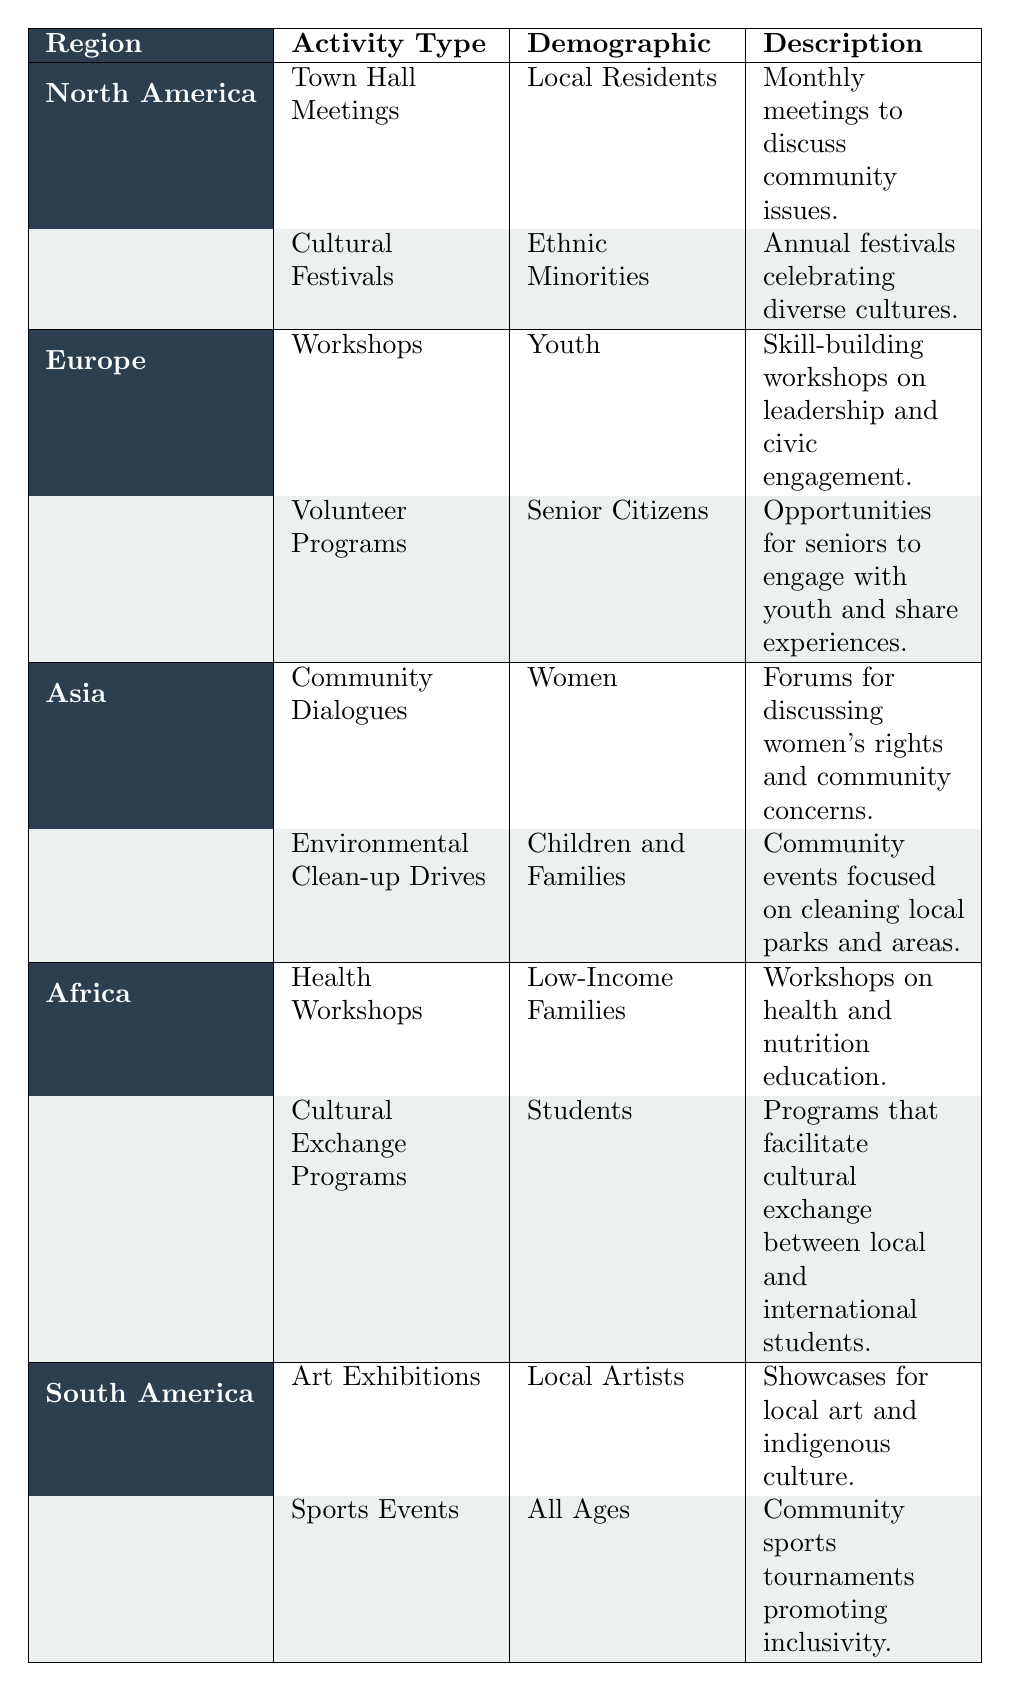What types of activities are listed for Asia? The table shows two activities for Asia: "Community Dialogues" for Women and "Environmental Clean-up Drives" for Children and Families.
Answer: Community Dialogues, Environmental Clean-up Drives Which demographic is targeted by the Cultural Festivals in North America? The Cultural Festivals in North America aim to engage Ethnic Minorities, as indicated in the table.
Answer: Ethnic Minorities Are there any activities listed for Europe that engage Senior Citizens? Yes, there is a "Volunteer Programs" activity listed for Senior Citizens in Europe.
Answer: Yes How many high engagement level activities are listed in Africa? In the Africa region, there is one high engagement activity: "Health Workshops" for Low-Income Families. This concludes that there is only one activity with high engagement levels.
Answer: 1 What is the total number of activities that target Local Residents across all regions? The only activity targeting Local Residents is "Town Hall Meetings" listed under North America. Therefore, the total is one.
Answer: 1 Which region has activities focused on cleaning local parks? The "Environmental Clean-up Drives" are focused on cleaning local parks and are listed under the Asia region.
Answer: Asia Is the "Art Exhibitions" activity aimed at children? No, the "Art Exhibitions" target Local Artists, not children.
Answer: No Are there more activities with high engagement levels or medium engagement levels across all regions? Upon evaluating the table, there are a total of 5 high engagement activities and 5 medium engagement activities. Therefore, there is an equal number of both.
Answer: Equal number of high and medium engagement activities What percentage of activities listed in South America are aimed at promoting inclusivity? In South America, there are 2 activities, with 1 being "Sports Events," which promotes inclusivity. Thus, the percentage is calculated as (1/2)*100 = 50%.
Answer: 50% 